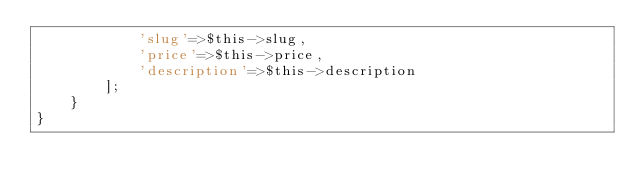Convert code to text. <code><loc_0><loc_0><loc_500><loc_500><_PHP_>            'slug'=>$this->slug,
            'price'=>$this->price,
            'description'=>$this->description
        ];
    }
}
</code> 